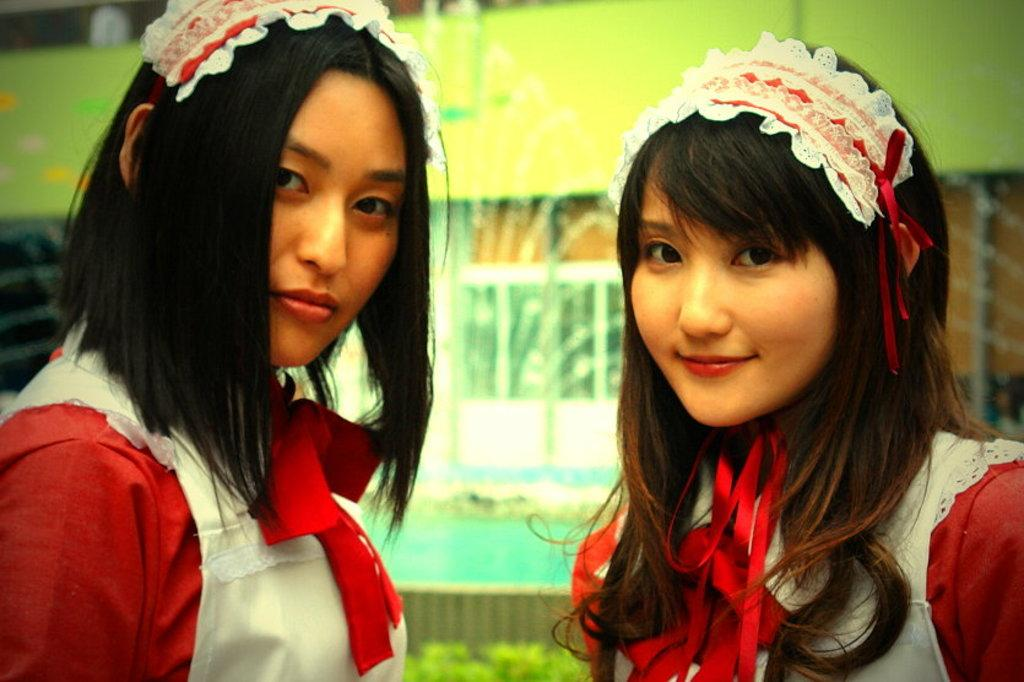How many people are in the image? There are two persons in the image. What can be observed about their appearance? The persons are in different costumes. Can you describe the facial expression of one of the persons? The person on the right side is smiling. How would you describe the background of the image? The background of the image is blurred. What type of cart can be seen in the image? There is no cart present in the image. Is there any dirt visible on the persons' costumes in the image? There is no dirt visible on the persons' costumes in the image. 